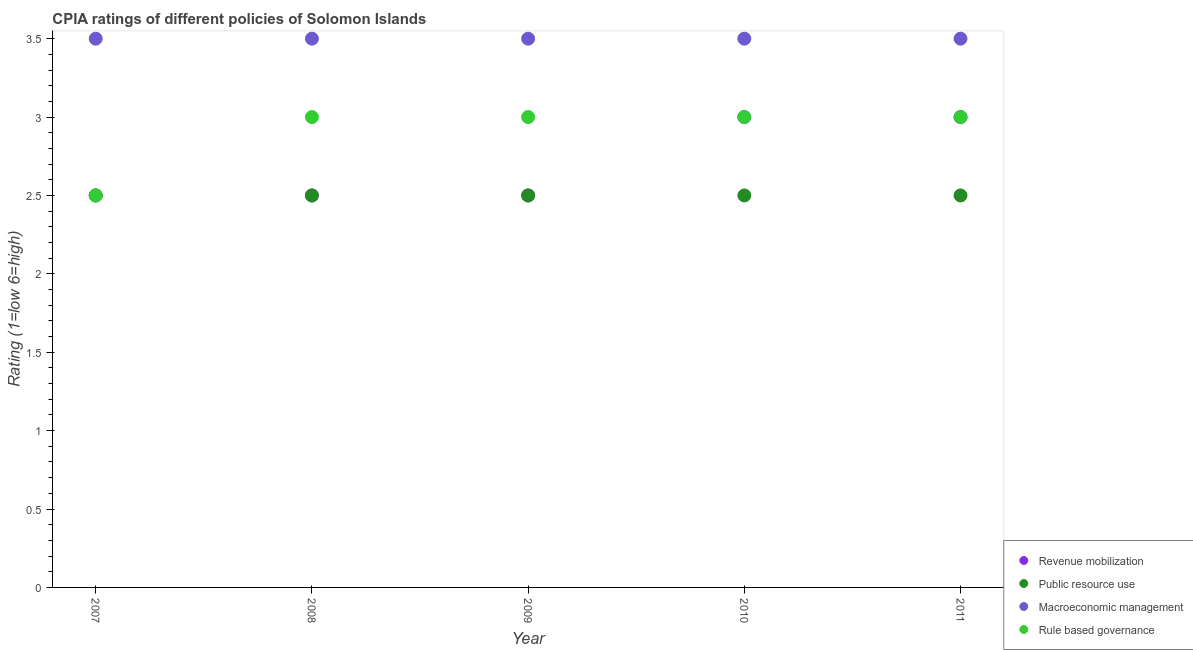How many different coloured dotlines are there?
Give a very brief answer. 4. Is the number of dotlines equal to the number of legend labels?
Give a very brief answer. Yes. What is the cpia rating of macroeconomic management in 2008?
Your answer should be compact. 3.5. Across all years, what is the maximum cpia rating of macroeconomic management?
Provide a short and direct response. 3.5. In which year was the cpia rating of revenue mobilization maximum?
Keep it short and to the point. 2010. What is the difference between the cpia rating of rule based governance in 2008 and that in 2011?
Offer a very short reply. 0. In the year 2011, what is the difference between the cpia rating of revenue mobilization and cpia rating of rule based governance?
Your answer should be very brief. 0. What is the ratio of the cpia rating of rule based governance in 2008 to that in 2010?
Make the answer very short. 1. Is the difference between the cpia rating of revenue mobilization in 2007 and 2008 greater than the difference between the cpia rating of rule based governance in 2007 and 2008?
Your answer should be very brief. Yes. Is the sum of the cpia rating of macroeconomic management in 2008 and 2011 greater than the maximum cpia rating of rule based governance across all years?
Offer a terse response. Yes. Is it the case that in every year, the sum of the cpia rating of revenue mobilization and cpia rating of public resource use is greater than the cpia rating of macroeconomic management?
Your answer should be compact. Yes. Is the cpia rating of rule based governance strictly greater than the cpia rating of revenue mobilization over the years?
Provide a succinct answer. No. Is the cpia rating of revenue mobilization strictly less than the cpia rating of macroeconomic management over the years?
Ensure brevity in your answer.  Yes. What is the difference between two consecutive major ticks on the Y-axis?
Offer a terse response. 0.5. Are the values on the major ticks of Y-axis written in scientific E-notation?
Your response must be concise. No. Does the graph contain any zero values?
Offer a very short reply. No. Does the graph contain grids?
Give a very brief answer. No. Where does the legend appear in the graph?
Ensure brevity in your answer.  Bottom right. How many legend labels are there?
Offer a very short reply. 4. How are the legend labels stacked?
Offer a terse response. Vertical. What is the title of the graph?
Provide a succinct answer. CPIA ratings of different policies of Solomon Islands. Does "Fourth 20% of population" appear as one of the legend labels in the graph?
Make the answer very short. No. What is the label or title of the Y-axis?
Your answer should be very brief. Rating (1=low 6=high). What is the Rating (1=low 6=high) in Public resource use in 2007?
Provide a short and direct response. 2.5. What is the Rating (1=low 6=high) in Rule based governance in 2007?
Ensure brevity in your answer.  2.5. What is the Rating (1=low 6=high) in Revenue mobilization in 2008?
Your answer should be compact. 2.5. What is the Rating (1=low 6=high) of Public resource use in 2008?
Provide a succinct answer. 2.5. What is the Rating (1=low 6=high) in Revenue mobilization in 2009?
Offer a very short reply. 2.5. What is the Rating (1=low 6=high) in Public resource use in 2009?
Ensure brevity in your answer.  2.5. What is the Rating (1=low 6=high) in Macroeconomic management in 2010?
Give a very brief answer. 3.5. What is the Rating (1=low 6=high) in Revenue mobilization in 2011?
Make the answer very short. 3. Across all years, what is the maximum Rating (1=low 6=high) of Revenue mobilization?
Make the answer very short. 3. Across all years, what is the maximum Rating (1=low 6=high) in Macroeconomic management?
Your answer should be compact. 3.5. Across all years, what is the maximum Rating (1=low 6=high) of Rule based governance?
Your response must be concise. 3. Across all years, what is the minimum Rating (1=low 6=high) of Public resource use?
Give a very brief answer. 2.5. Across all years, what is the minimum Rating (1=low 6=high) of Rule based governance?
Provide a succinct answer. 2.5. What is the total Rating (1=low 6=high) of Revenue mobilization in the graph?
Keep it short and to the point. 13.5. What is the total Rating (1=low 6=high) of Macroeconomic management in the graph?
Offer a very short reply. 17.5. What is the total Rating (1=low 6=high) of Rule based governance in the graph?
Offer a very short reply. 14.5. What is the difference between the Rating (1=low 6=high) in Rule based governance in 2007 and that in 2008?
Offer a terse response. -0.5. What is the difference between the Rating (1=low 6=high) in Revenue mobilization in 2007 and that in 2009?
Offer a very short reply. 0. What is the difference between the Rating (1=low 6=high) of Rule based governance in 2007 and that in 2009?
Ensure brevity in your answer.  -0.5. What is the difference between the Rating (1=low 6=high) in Public resource use in 2007 and that in 2010?
Offer a terse response. 0. What is the difference between the Rating (1=low 6=high) in Macroeconomic management in 2007 and that in 2010?
Your answer should be compact. 0. What is the difference between the Rating (1=low 6=high) in Rule based governance in 2007 and that in 2010?
Offer a very short reply. -0.5. What is the difference between the Rating (1=low 6=high) in Revenue mobilization in 2008 and that in 2009?
Give a very brief answer. 0. What is the difference between the Rating (1=low 6=high) in Macroeconomic management in 2008 and that in 2009?
Your answer should be very brief. 0. What is the difference between the Rating (1=low 6=high) of Rule based governance in 2008 and that in 2009?
Provide a short and direct response. 0. What is the difference between the Rating (1=low 6=high) in Revenue mobilization in 2008 and that in 2010?
Your answer should be compact. -0.5. What is the difference between the Rating (1=low 6=high) of Public resource use in 2008 and that in 2010?
Provide a short and direct response. 0. What is the difference between the Rating (1=low 6=high) in Rule based governance in 2008 and that in 2010?
Your response must be concise. 0. What is the difference between the Rating (1=low 6=high) in Public resource use in 2008 and that in 2011?
Make the answer very short. 0. What is the difference between the Rating (1=low 6=high) in Macroeconomic management in 2008 and that in 2011?
Provide a short and direct response. 0. What is the difference between the Rating (1=low 6=high) of Rule based governance in 2008 and that in 2011?
Keep it short and to the point. 0. What is the difference between the Rating (1=low 6=high) in Macroeconomic management in 2009 and that in 2010?
Provide a succinct answer. 0. What is the difference between the Rating (1=low 6=high) of Rule based governance in 2009 and that in 2010?
Provide a short and direct response. 0. What is the difference between the Rating (1=low 6=high) in Revenue mobilization in 2009 and that in 2011?
Provide a succinct answer. -0.5. What is the difference between the Rating (1=low 6=high) in Public resource use in 2009 and that in 2011?
Offer a very short reply. 0. What is the difference between the Rating (1=low 6=high) of Public resource use in 2010 and that in 2011?
Your answer should be very brief. 0. What is the difference between the Rating (1=low 6=high) in Revenue mobilization in 2007 and the Rating (1=low 6=high) in Public resource use in 2008?
Offer a terse response. 0. What is the difference between the Rating (1=low 6=high) in Revenue mobilization in 2007 and the Rating (1=low 6=high) in Public resource use in 2009?
Make the answer very short. 0. What is the difference between the Rating (1=low 6=high) of Revenue mobilization in 2007 and the Rating (1=low 6=high) of Rule based governance in 2009?
Offer a terse response. -0.5. What is the difference between the Rating (1=low 6=high) in Macroeconomic management in 2007 and the Rating (1=low 6=high) in Rule based governance in 2009?
Ensure brevity in your answer.  0.5. What is the difference between the Rating (1=low 6=high) in Revenue mobilization in 2007 and the Rating (1=low 6=high) in Rule based governance in 2010?
Provide a short and direct response. -0.5. What is the difference between the Rating (1=low 6=high) in Public resource use in 2007 and the Rating (1=low 6=high) in Macroeconomic management in 2010?
Give a very brief answer. -1. What is the difference between the Rating (1=low 6=high) of Revenue mobilization in 2007 and the Rating (1=low 6=high) of Public resource use in 2011?
Make the answer very short. 0. What is the difference between the Rating (1=low 6=high) in Macroeconomic management in 2007 and the Rating (1=low 6=high) in Rule based governance in 2011?
Provide a succinct answer. 0.5. What is the difference between the Rating (1=low 6=high) in Revenue mobilization in 2008 and the Rating (1=low 6=high) in Public resource use in 2009?
Provide a succinct answer. 0. What is the difference between the Rating (1=low 6=high) of Revenue mobilization in 2008 and the Rating (1=low 6=high) of Rule based governance in 2009?
Provide a short and direct response. -0.5. What is the difference between the Rating (1=low 6=high) of Macroeconomic management in 2008 and the Rating (1=low 6=high) of Rule based governance in 2009?
Your answer should be compact. 0.5. What is the difference between the Rating (1=low 6=high) in Revenue mobilization in 2008 and the Rating (1=low 6=high) in Public resource use in 2010?
Make the answer very short. 0. What is the difference between the Rating (1=low 6=high) of Revenue mobilization in 2008 and the Rating (1=low 6=high) of Macroeconomic management in 2010?
Provide a short and direct response. -1. What is the difference between the Rating (1=low 6=high) of Revenue mobilization in 2008 and the Rating (1=low 6=high) of Rule based governance in 2010?
Provide a short and direct response. -0.5. What is the difference between the Rating (1=low 6=high) in Revenue mobilization in 2008 and the Rating (1=low 6=high) in Public resource use in 2011?
Your answer should be compact. 0. What is the difference between the Rating (1=low 6=high) in Revenue mobilization in 2008 and the Rating (1=low 6=high) in Macroeconomic management in 2011?
Keep it short and to the point. -1. What is the difference between the Rating (1=low 6=high) in Public resource use in 2008 and the Rating (1=low 6=high) in Rule based governance in 2011?
Offer a terse response. -0.5. What is the difference between the Rating (1=low 6=high) in Revenue mobilization in 2009 and the Rating (1=low 6=high) in Public resource use in 2010?
Give a very brief answer. 0. What is the difference between the Rating (1=low 6=high) of Revenue mobilization in 2009 and the Rating (1=low 6=high) of Macroeconomic management in 2010?
Your answer should be very brief. -1. What is the difference between the Rating (1=low 6=high) in Revenue mobilization in 2009 and the Rating (1=low 6=high) in Rule based governance in 2010?
Keep it short and to the point. -0.5. What is the difference between the Rating (1=low 6=high) in Public resource use in 2009 and the Rating (1=low 6=high) in Rule based governance in 2010?
Ensure brevity in your answer.  -0.5. What is the difference between the Rating (1=low 6=high) of Public resource use in 2009 and the Rating (1=low 6=high) of Macroeconomic management in 2011?
Provide a short and direct response. -1. What is the difference between the Rating (1=low 6=high) in Macroeconomic management in 2009 and the Rating (1=low 6=high) in Rule based governance in 2011?
Give a very brief answer. 0.5. What is the difference between the Rating (1=low 6=high) in Public resource use in 2010 and the Rating (1=low 6=high) in Macroeconomic management in 2011?
Ensure brevity in your answer.  -1. What is the average Rating (1=low 6=high) of Revenue mobilization per year?
Your answer should be very brief. 2.7. What is the average Rating (1=low 6=high) in Rule based governance per year?
Keep it short and to the point. 2.9. In the year 2007, what is the difference between the Rating (1=low 6=high) in Revenue mobilization and Rating (1=low 6=high) in Macroeconomic management?
Offer a very short reply. -1. In the year 2007, what is the difference between the Rating (1=low 6=high) of Public resource use and Rating (1=low 6=high) of Macroeconomic management?
Your response must be concise. -1. In the year 2008, what is the difference between the Rating (1=low 6=high) of Revenue mobilization and Rating (1=low 6=high) of Public resource use?
Ensure brevity in your answer.  0. In the year 2008, what is the difference between the Rating (1=low 6=high) of Revenue mobilization and Rating (1=low 6=high) of Rule based governance?
Give a very brief answer. -0.5. In the year 2008, what is the difference between the Rating (1=low 6=high) of Public resource use and Rating (1=low 6=high) of Macroeconomic management?
Provide a succinct answer. -1. In the year 2009, what is the difference between the Rating (1=low 6=high) in Revenue mobilization and Rating (1=low 6=high) in Macroeconomic management?
Provide a short and direct response. -1. In the year 2009, what is the difference between the Rating (1=low 6=high) of Revenue mobilization and Rating (1=low 6=high) of Rule based governance?
Offer a very short reply. -0.5. In the year 2009, what is the difference between the Rating (1=low 6=high) in Public resource use and Rating (1=low 6=high) in Macroeconomic management?
Keep it short and to the point. -1. In the year 2009, what is the difference between the Rating (1=low 6=high) of Macroeconomic management and Rating (1=low 6=high) of Rule based governance?
Offer a terse response. 0.5. In the year 2010, what is the difference between the Rating (1=low 6=high) of Revenue mobilization and Rating (1=low 6=high) of Macroeconomic management?
Offer a terse response. -0.5. In the year 2010, what is the difference between the Rating (1=low 6=high) of Public resource use and Rating (1=low 6=high) of Macroeconomic management?
Give a very brief answer. -1. In the year 2010, what is the difference between the Rating (1=low 6=high) of Public resource use and Rating (1=low 6=high) of Rule based governance?
Keep it short and to the point. -0.5. In the year 2010, what is the difference between the Rating (1=low 6=high) in Macroeconomic management and Rating (1=low 6=high) in Rule based governance?
Make the answer very short. 0.5. In the year 2011, what is the difference between the Rating (1=low 6=high) of Revenue mobilization and Rating (1=low 6=high) of Public resource use?
Offer a terse response. 0.5. In the year 2011, what is the difference between the Rating (1=low 6=high) of Revenue mobilization and Rating (1=low 6=high) of Macroeconomic management?
Ensure brevity in your answer.  -0.5. What is the ratio of the Rating (1=low 6=high) of Rule based governance in 2007 to that in 2008?
Offer a very short reply. 0.83. What is the ratio of the Rating (1=low 6=high) in Revenue mobilization in 2007 to that in 2009?
Ensure brevity in your answer.  1. What is the ratio of the Rating (1=low 6=high) in Revenue mobilization in 2007 to that in 2010?
Offer a terse response. 0.83. What is the ratio of the Rating (1=low 6=high) of Macroeconomic management in 2007 to that in 2010?
Your answer should be compact. 1. What is the ratio of the Rating (1=low 6=high) of Revenue mobilization in 2007 to that in 2011?
Offer a very short reply. 0.83. What is the ratio of the Rating (1=low 6=high) in Macroeconomic management in 2008 to that in 2009?
Provide a succinct answer. 1. What is the ratio of the Rating (1=low 6=high) in Rule based governance in 2008 to that in 2009?
Provide a short and direct response. 1. What is the ratio of the Rating (1=low 6=high) in Macroeconomic management in 2008 to that in 2010?
Your response must be concise. 1. What is the ratio of the Rating (1=low 6=high) in Macroeconomic management in 2008 to that in 2011?
Your answer should be very brief. 1. What is the ratio of the Rating (1=low 6=high) in Rule based governance in 2008 to that in 2011?
Your answer should be compact. 1. What is the ratio of the Rating (1=low 6=high) of Revenue mobilization in 2009 to that in 2010?
Your answer should be very brief. 0.83. What is the ratio of the Rating (1=low 6=high) in Macroeconomic management in 2009 to that in 2010?
Offer a very short reply. 1. What is the ratio of the Rating (1=low 6=high) of Rule based governance in 2009 to that in 2010?
Your answer should be compact. 1. What is the ratio of the Rating (1=low 6=high) in Public resource use in 2009 to that in 2011?
Provide a short and direct response. 1. What is the ratio of the Rating (1=low 6=high) of Rule based governance in 2009 to that in 2011?
Give a very brief answer. 1. What is the ratio of the Rating (1=low 6=high) of Revenue mobilization in 2010 to that in 2011?
Your answer should be compact. 1. What is the ratio of the Rating (1=low 6=high) of Public resource use in 2010 to that in 2011?
Offer a very short reply. 1. What is the difference between the highest and the second highest Rating (1=low 6=high) of Revenue mobilization?
Ensure brevity in your answer.  0. What is the difference between the highest and the second highest Rating (1=low 6=high) of Macroeconomic management?
Give a very brief answer. 0. What is the difference between the highest and the lowest Rating (1=low 6=high) of Revenue mobilization?
Offer a terse response. 0.5. What is the difference between the highest and the lowest Rating (1=low 6=high) of Public resource use?
Provide a succinct answer. 0. 